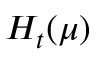Convert formula to latex. <formula><loc_0><loc_0><loc_500><loc_500>H _ { t } ( \mu )</formula> 